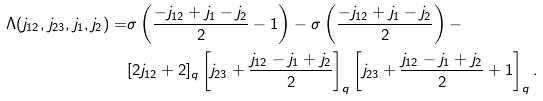<formula> <loc_0><loc_0><loc_500><loc_500>\Lambda ( j _ { 1 2 } , j _ { 2 3 } , j _ { 1 } , j _ { 2 } ) = & \sigma \left ( \frac { - j _ { 1 2 } + j _ { 1 } - j _ { 2 } } 2 - 1 \right ) - \sigma \left ( \frac { - j _ { 1 2 } + j _ { 1 } - j _ { 2 } } 2 \right ) - \\ & [ 2 j _ { 1 2 } + 2 ] _ { q } \left [ j _ { 2 3 } + \frac { j _ { 1 2 } - j _ { 1 } + j _ { 2 } } 2 \right ] _ { q } \left [ j _ { 2 3 } + \frac { j _ { 1 2 } - j _ { 1 } + j _ { 2 } } 2 + 1 \right ] _ { q } .</formula> 